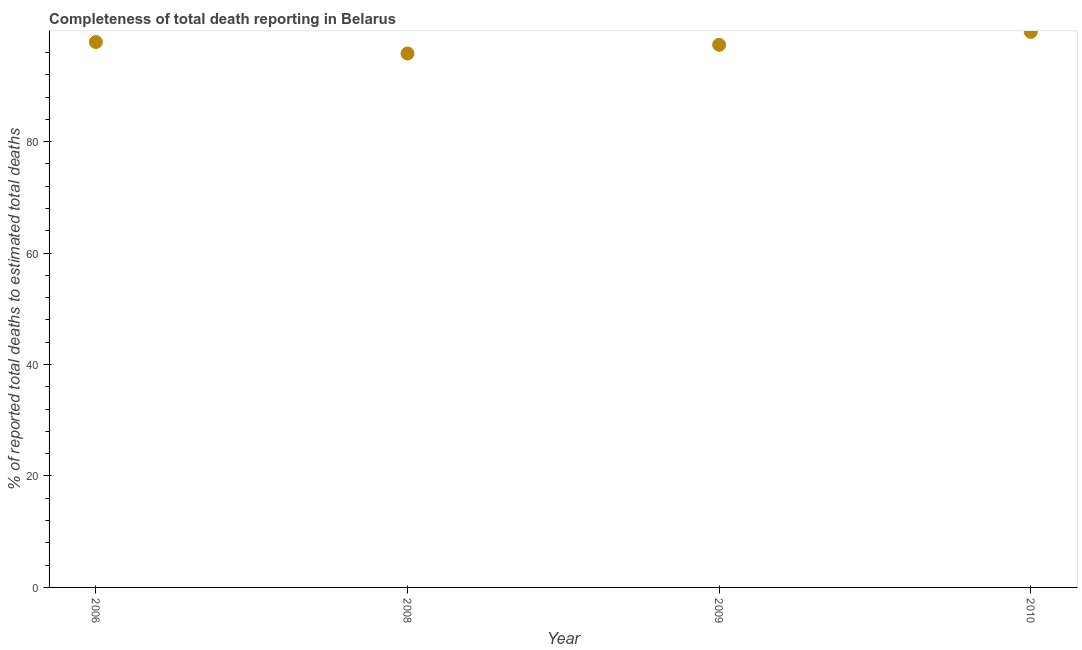What is the completeness of total death reports in 2010?
Give a very brief answer. 99.71. Across all years, what is the maximum completeness of total death reports?
Provide a succinct answer. 99.71. Across all years, what is the minimum completeness of total death reports?
Keep it short and to the point. 95.83. What is the sum of the completeness of total death reports?
Your response must be concise. 390.82. What is the difference between the completeness of total death reports in 2008 and 2009?
Ensure brevity in your answer.  -1.56. What is the average completeness of total death reports per year?
Ensure brevity in your answer.  97.7. What is the median completeness of total death reports?
Offer a terse response. 97.64. What is the ratio of the completeness of total death reports in 2006 to that in 2008?
Ensure brevity in your answer.  1.02. Is the completeness of total death reports in 2009 less than that in 2010?
Make the answer very short. Yes. Is the difference between the completeness of total death reports in 2006 and 2010 greater than the difference between any two years?
Your response must be concise. No. What is the difference between the highest and the second highest completeness of total death reports?
Ensure brevity in your answer.  1.82. Is the sum of the completeness of total death reports in 2006 and 2010 greater than the maximum completeness of total death reports across all years?
Make the answer very short. Yes. What is the difference between the highest and the lowest completeness of total death reports?
Offer a very short reply. 3.87. In how many years, is the completeness of total death reports greater than the average completeness of total death reports taken over all years?
Your answer should be very brief. 2. How many dotlines are there?
Offer a terse response. 1. How many years are there in the graph?
Give a very brief answer. 4. What is the difference between two consecutive major ticks on the Y-axis?
Provide a succinct answer. 20. Are the values on the major ticks of Y-axis written in scientific E-notation?
Keep it short and to the point. No. Does the graph contain any zero values?
Keep it short and to the point. No. What is the title of the graph?
Provide a short and direct response. Completeness of total death reporting in Belarus. What is the label or title of the Y-axis?
Your response must be concise. % of reported total deaths to estimated total deaths. What is the % of reported total deaths to estimated total deaths in 2006?
Your answer should be compact. 97.89. What is the % of reported total deaths to estimated total deaths in 2008?
Provide a succinct answer. 95.83. What is the % of reported total deaths to estimated total deaths in 2009?
Make the answer very short. 97.39. What is the % of reported total deaths to estimated total deaths in 2010?
Your response must be concise. 99.71. What is the difference between the % of reported total deaths to estimated total deaths in 2006 and 2008?
Provide a short and direct response. 2.06. What is the difference between the % of reported total deaths to estimated total deaths in 2006 and 2009?
Offer a terse response. 0.5. What is the difference between the % of reported total deaths to estimated total deaths in 2006 and 2010?
Offer a very short reply. -1.82. What is the difference between the % of reported total deaths to estimated total deaths in 2008 and 2009?
Give a very brief answer. -1.56. What is the difference between the % of reported total deaths to estimated total deaths in 2008 and 2010?
Your answer should be very brief. -3.87. What is the difference between the % of reported total deaths to estimated total deaths in 2009 and 2010?
Your answer should be compact. -2.32. What is the ratio of the % of reported total deaths to estimated total deaths in 2006 to that in 2010?
Your answer should be compact. 0.98. What is the ratio of the % of reported total deaths to estimated total deaths in 2009 to that in 2010?
Your response must be concise. 0.98. 